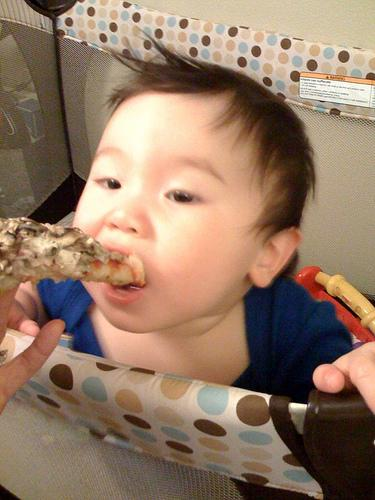Mention some items surrounding the baby. There is a yellow handled toy, a toy, and a mesh front on the playpen around the baby. Can you describe the hair and eyes of the infant? The baby has black hair and black eyes. What color is the baby's shirt? The baby is wearing a blue shirt. What color are the corner of the playpen? The corner of the playpen is brown and plastic. Describe what the person in the background is doing. There is another person in the background feeding the child. Comment on the appearance of the dots on the baby decoration. The dots on the baby decoration are polka and come in colors like blue and dark brown. What information can be seen on the playpen? There are warnings posted on the playpen. What pattern can be seen on the playpen and baby bedding? There is a polka dot pattern on the playpen and baby bedding. What is the baby eating in the image? The baby is eating a piece of pizza. How would you describe the baby's position? The baby is standing in the crib. 